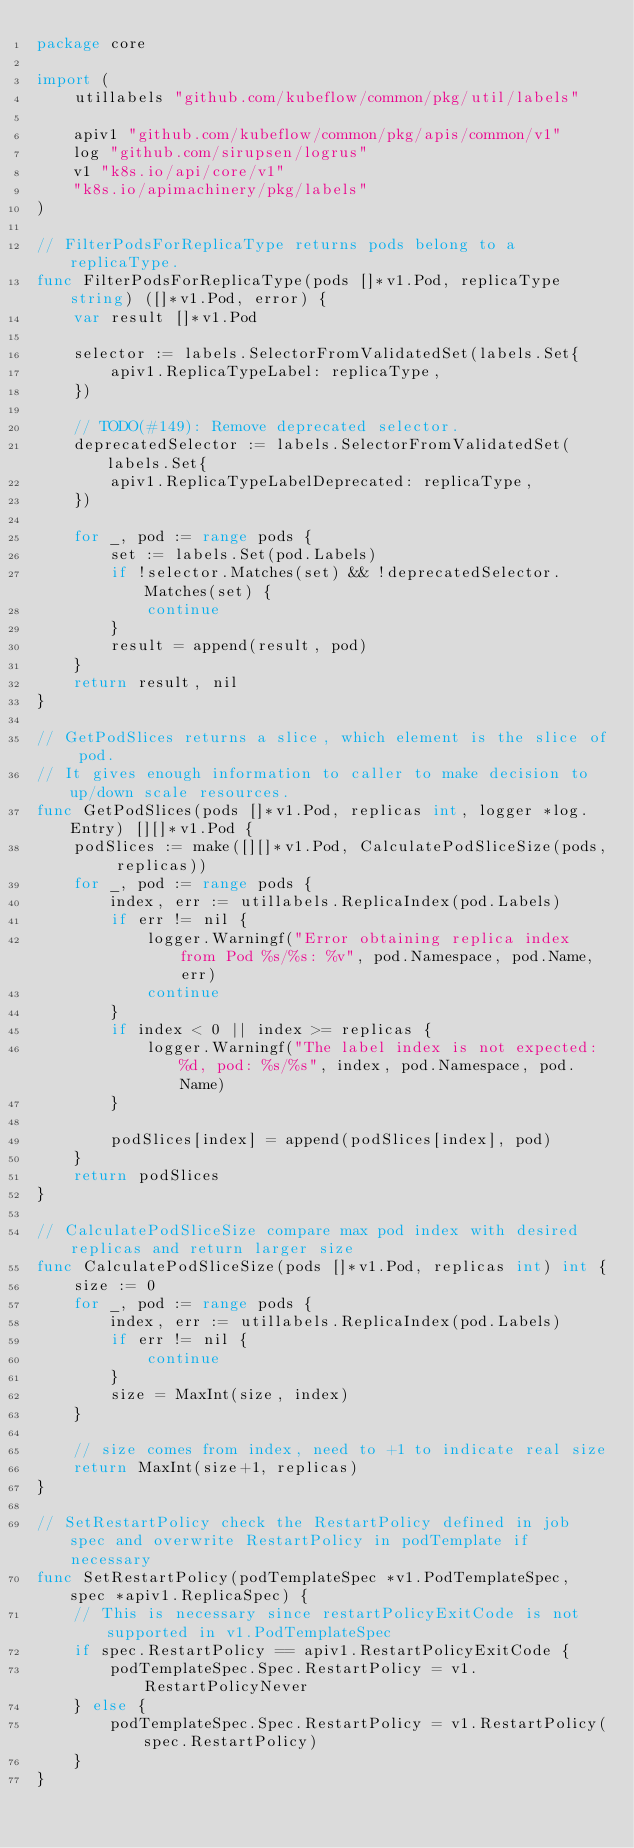<code> <loc_0><loc_0><loc_500><loc_500><_Go_>package core

import (
	utillabels "github.com/kubeflow/common/pkg/util/labels"

	apiv1 "github.com/kubeflow/common/pkg/apis/common/v1"
	log "github.com/sirupsen/logrus"
	v1 "k8s.io/api/core/v1"
	"k8s.io/apimachinery/pkg/labels"
)

// FilterPodsForReplicaType returns pods belong to a replicaType.
func FilterPodsForReplicaType(pods []*v1.Pod, replicaType string) ([]*v1.Pod, error) {
	var result []*v1.Pod

	selector := labels.SelectorFromValidatedSet(labels.Set{
		apiv1.ReplicaTypeLabel: replicaType,
	})

	// TODO(#149): Remove deprecated selector.
	deprecatedSelector := labels.SelectorFromValidatedSet(labels.Set{
		apiv1.ReplicaTypeLabelDeprecated: replicaType,
	})

	for _, pod := range pods {
		set := labels.Set(pod.Labels)
		if !selector.Matches(set) && !deprecatedSelector.Matches(set) {
			continue
		}
		result = append(result, pod)
	}
	return result, nil
}

// GetPodSlices returns a slice, which element is the slice of pod.
// It gives enough information to caller to make decision to up/down scale resources.
func GetPodSlices(pods []*v1.Pod, replicas int, logger *log.Entry) [][]*v1.Pod {
	podSlices := make([][]*v1.Pod, CalculatePodSliceSize(pods, replicas))
	for _, pod := range pods {
		index, err := utillabels.ReplicaIndex(pod.Labels)
		if err != nil {
			logger.Warningf("Error obtaining replica index from Pod %s/%s: %v", pod.Namespace, pod.Name, err)
			continue
		}
		if index < 0 || index >= replicas {
			logger.Warningf("The label index is not expected: %d, pod: %s/%s", index, pod.Namespace, pod.Name)
		}

		podSlices[index] = append(podSlices[index], pod)
	}
	return podSlices
}

// CalculatePodSliceSize compare max pod index with desired replicas and return larger size
func CalculatePodSliceSize(pods []*v1.Pod, replicas int) int {
	size := 0
	for _, pod := range pods {
		index, err := utillabels.ReplicaIndex(pod.Labels)
		if err != nil {
			continue
		}
		size = MaxInt(size, index)
	}

	// size comes from index, need to +1 to indicate real size
	return MaxInt(size+1, replicas)
}

// SetRestartPolicy check the RestartPolicy defined in job spec and overwrite RestartPolicy in podTemplate if necessary
func SetRestartPolicy(podTemplateSpec *v1.PodTemplateSpec, spec *apiv1.ReplicaSpec) {
	// This is necessary since restartPolicyExitCode is not supported in v1.PodTemplateSpec
	if spec.RestartPolicy == apiv1.RestartPolicyExitCode {
		podTemplateSpec.Spec.RestartPolicy = v1.RestartPolicyNever
	} else {
		podTemplateSpec.Spec.RestartPolicy = v1.RestartPolicy(spec.RestartPolicy)
	}
}
</code> 